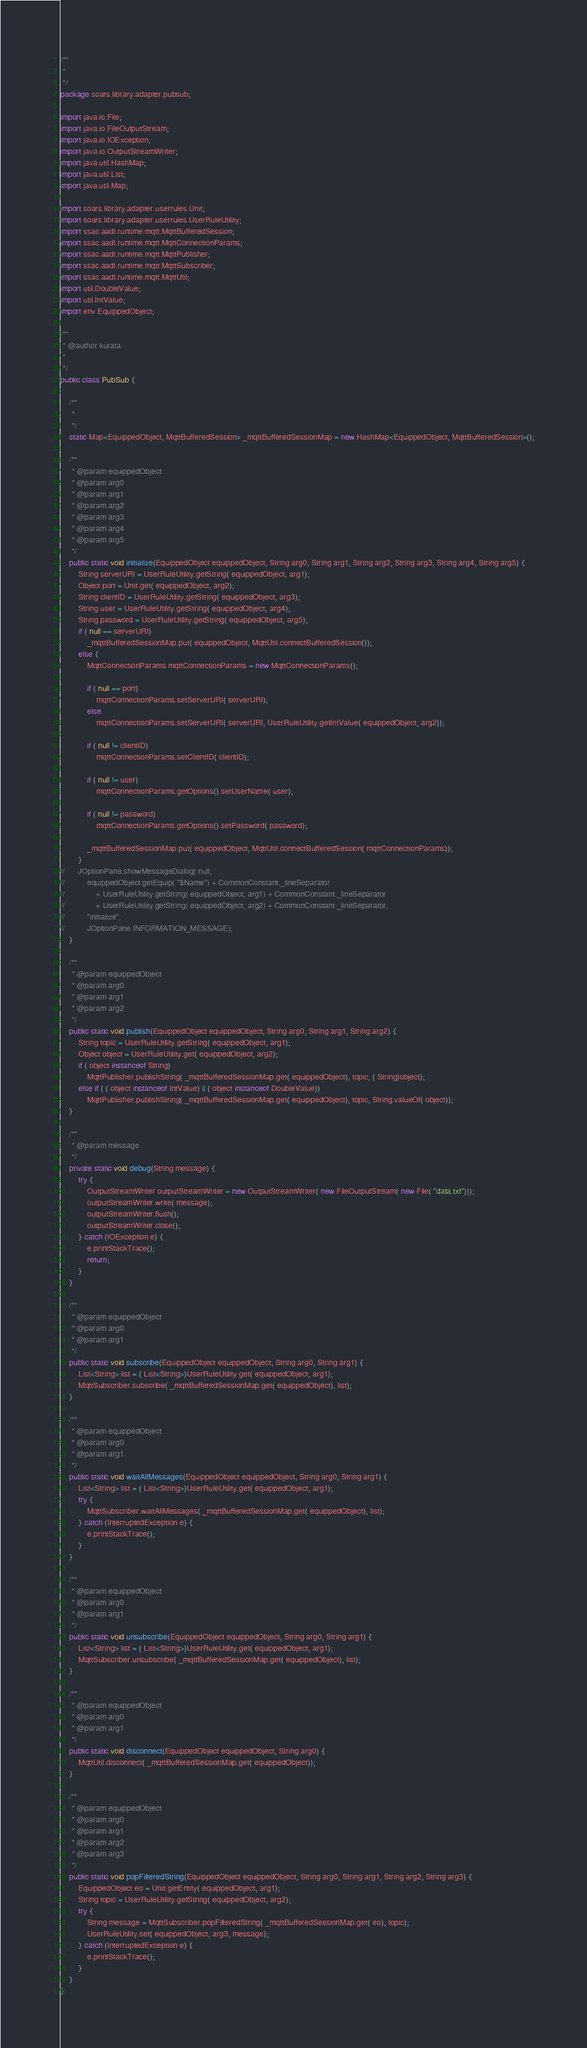Convert code to text. <code><loc_0><loc_0><loc_500><loc_500><_Java_>/**
 * 
 */
package soars.library.adapter.pubsub;

import java.io.File;
import java.io.FileOutputStream;
import java.io.IOException;
import java.io.OutputStreamWriter;
import java.util.HashMap;
import java.util.List;
import java.util.Map;

import soars.library.adapter.userrules.Unit;
import soars.library.adapter.userrules.UserRuleUtility;
import ssac.aadl.runtime.mqtt.MqttBufferedSession;
import ssac.aadl.runtime.mqtt.MqttConnectionParams;
import ssac.aadl.runtime.mqtt.MqttPublisher;
import ssac.aadl.runtime.mqtt.MqttSubscriber;
import ssac.aadl.runtime.mqtt.MqttUtil;
import util.DoubleValue;
import util.IntValue;
import env.EquippedObject;

/**
 * @author kurata
 *
 */
public class PubSub {

	/**
	 * 
	 */
	static Map<EquippedObject, MqttBufferedSession> _mqttBufferedSessionMap = new HashMap<EquippedObject, MqttBufferedSession>();

	/**
	 * @param equippedObject
	 * @param arg0
	 * @param arg1
	 * @param arg2
	 * @param arg3
	 * @param arg4
	 * @param arg5
	 */
	public static void initialize(EquippedObject equippedObject, String arg0, String arg1, String arg2, String arg3, String arg4, String arg5) {
		String serverURI = UserRuleUtility.getString( equippedObject, arg1);
		Object port = Unit.get( equippedObject, arg2);
		String clientID = UserRuleUtility.getString( equippedObject, arg3);
		String user = UserRuleUtility.getString( equippedObject, arg4);
		String password = UserRuleUtility.getString( equippedObject, arg5);
		if ( null == serverURI)
			_mqttBufferedSessionMap.put( equippedObject, MqttUtil.connectBufferedSession());
		else {
			MqttConnectionParams mqttConnectionParams = new MqttConnectionParams();

			if ( null == port)
				mqttConnectionParams.setServerURI( serverURI);
			else
				mqttConnectionParams.setServerURI( serverURI, UserRuleUtility.getIntValue( equippedObject, arg2));

			if ( null != clientID)
				mqttConnectionParams.setClientID( clientID);

			if ( null != user)
				mqttConnectionParams.getOptions().setUserName( user);

			if ( null != password)
				mqttConnectionParams.getOptions().setPassword( password);

			_mqttBufferedSessionMap.put( equippedObject, MqttUtil.connectBufferedSession( mqttConnectionParams));
		}
//		JOptionPane.showMessageDialog( null,
//			equippedObject.getEquip( "$Name") + CommonConstant._lineSeparator
//				+ UserRuleUtility.getString( equippedObject, arg1) + CommonConstant._lineSeparator
//				+ UserRuleUtility.getString( equippedObject, arg2) + CommonConstant._lineSeparator,
//			"initialize",
//			JOptionPane.INFORMATION_MESSAGE);
	}

	/**
	 * @param equippedObject
	 * @param arg0
	 * @param arg1
	 * @param arg2
	 */
	public static void publish(EquippedObject equippedObject, String arg0, String arg1, String arg2) {
		String topic = UserRuleUtility.getString( equippedObject, arg1);
		Object object = UserRuleUtility.get( equippedObject, arg2);
		if ( object instanceof String)
			MqttPublisher.publishString( _mqttBufferedSessionMap.get( equippedObject), topic, ( String)object);
		else if ( ( object instanceof IntValue) || ( object instanceof DoubleValue))
			MqttPublisher.publishString( _mqttBufferedSessionMap.get( equippedObject), topic, String.valueOf( object));
	}

	/**
	 * @param message
	 */
	private static void debug(String message) {
		try {
			OutputStreamWriter outputStreamWriter = new OutputStreamWriter( new FileOutputStream( new File( "data.txt")));
			outputStreamWriter.write( message);
			outputStreamWriter.flush();
			outputStreamWriter.close();
		} catch (IOException e) {
			e.printStackTrace();
			return;
		}
	}

	/**
	 * @param equippedObject
	 * @param arg0
	 * @param arg1
	 */
	public static void subscribe(EquippedObject equippedObject, String arg0, String arg1) {
		List<String> list = ( List<String>)UserRuleUtility.get( equippedObject, arg1);
		MqttSubscriber.subscribe( _mqttBufferedSessionMap.get( equippedObject), list);
	}

	/**
	 * @param equippedObject
	 * @param arg0
	 * @param arg1
	 */
	public static void waitAllMessages(EquippedObject equippedObject, String arg0, String arg1) {
		List<String> list = ( List<String>)UserRuleUtility.get( equippedObject, arg1);
		try {
			MqttSubscriber.waitAllMessages( _mqttBufferedSessionMap.get( equippedObject), list);
		} catch (InterruptedException e) {
			e.printStackTrace();
		}
	}

	/**
	 * @param equippedObject
	 * @param arg0
	 * @param arg1
	 */
	public static void unsubscribe(EquippedObject equippedObject, String arg0, String arg1) {
		List<String> list = ( List<String>)UserRuleUtility.get( equippedObject, arg1);
		MqttSubscriber.unsubscribe( _mqttBufferedSessionMap.get( equippedObject), list);
	}

	/**
	 * @param equippedObject
	 * @param arg0
	 * @param arg1
	 */
	public static void disconnect(EquippedObject equippedObject, String arg0) {
		MqttUtil.disconnect( _mqttBufferedSessionMap.get( equippedObject));
	}

	/**
	 * @param equippedObject
	 * @param arg0
	 * @param arg1
	 * @param arg2
	 * @param arg3
	 */
	public static void popFilteredString(EquippedObject equippedObject, String arg0, String arg1, String arg2, String arg3) {
		EquippedObject eo = Unit.getEntity( equippedObject, arg1);
		String topic = UserRuleUtility.getString( equippedObject, arg2);
		try {
			String message = MqttSubscriber.popFilteredString( _mqttBufferedSessionMap.get( eo), topic);
			UserRuleUtility.set( equippedObject, arg3, message);
		} catch (InterruptedException e) {
			e.printStackTrace();
		}
	}
}
</code> 